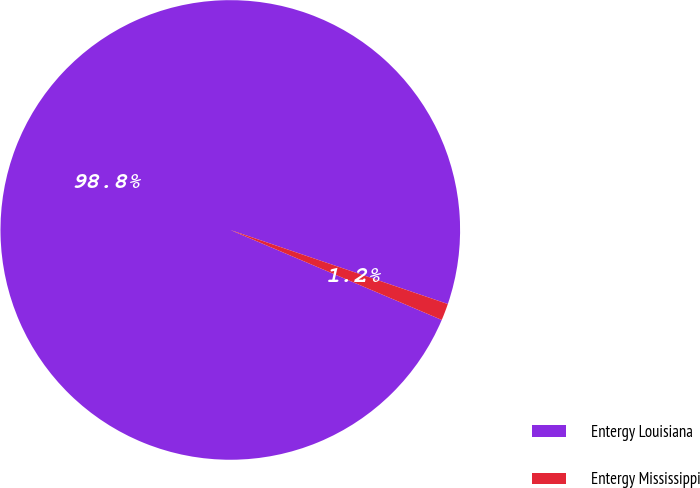Convert chart to OTSL. <chart><loc_0><loc_0><loc_500><loc_500><pie_chart><fcel>Entergy Louisiana<fcel>Entergy Mississippi<nl><fcel>98.82%<fcel>1.18%<nl></chart> 